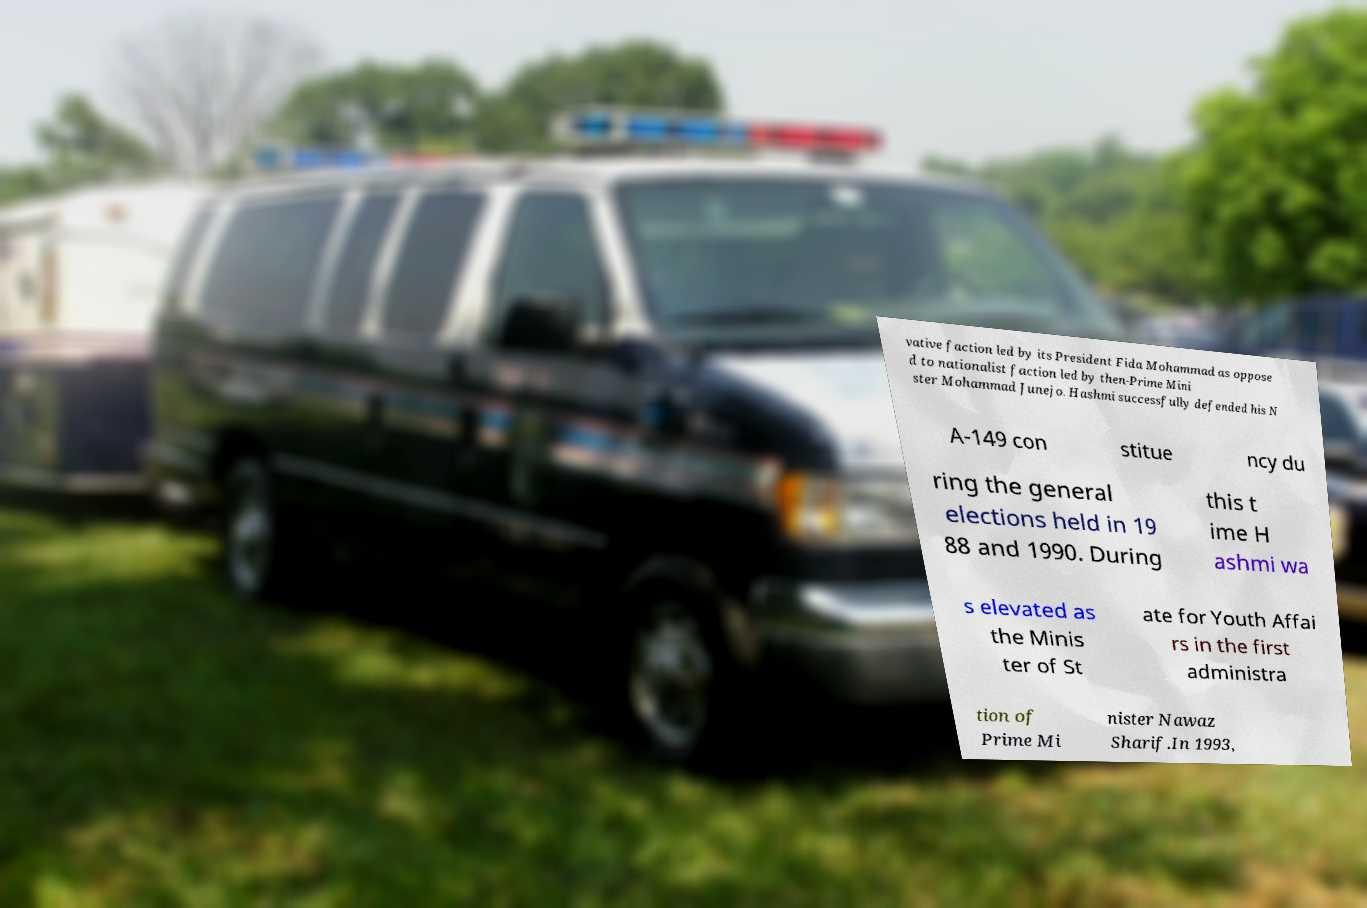There's text embedded in this image that I need extracted. Can you transcribe it verbatim? vative faction led by its President Fida Mohammad as oppose d to nationalist faction led by then-Prime Mini ster Mohammad Junejo. Hashmi successfully defended his N A-149 con stitue ncy du ring the general elections held in 19 88 and 1990. During this t ime H ashmi wa s elevated as the Minis ter of St ate for Youth Affai rs in the first administra tion of Prime Mi nister Nawaz Sharif.In 1993, 